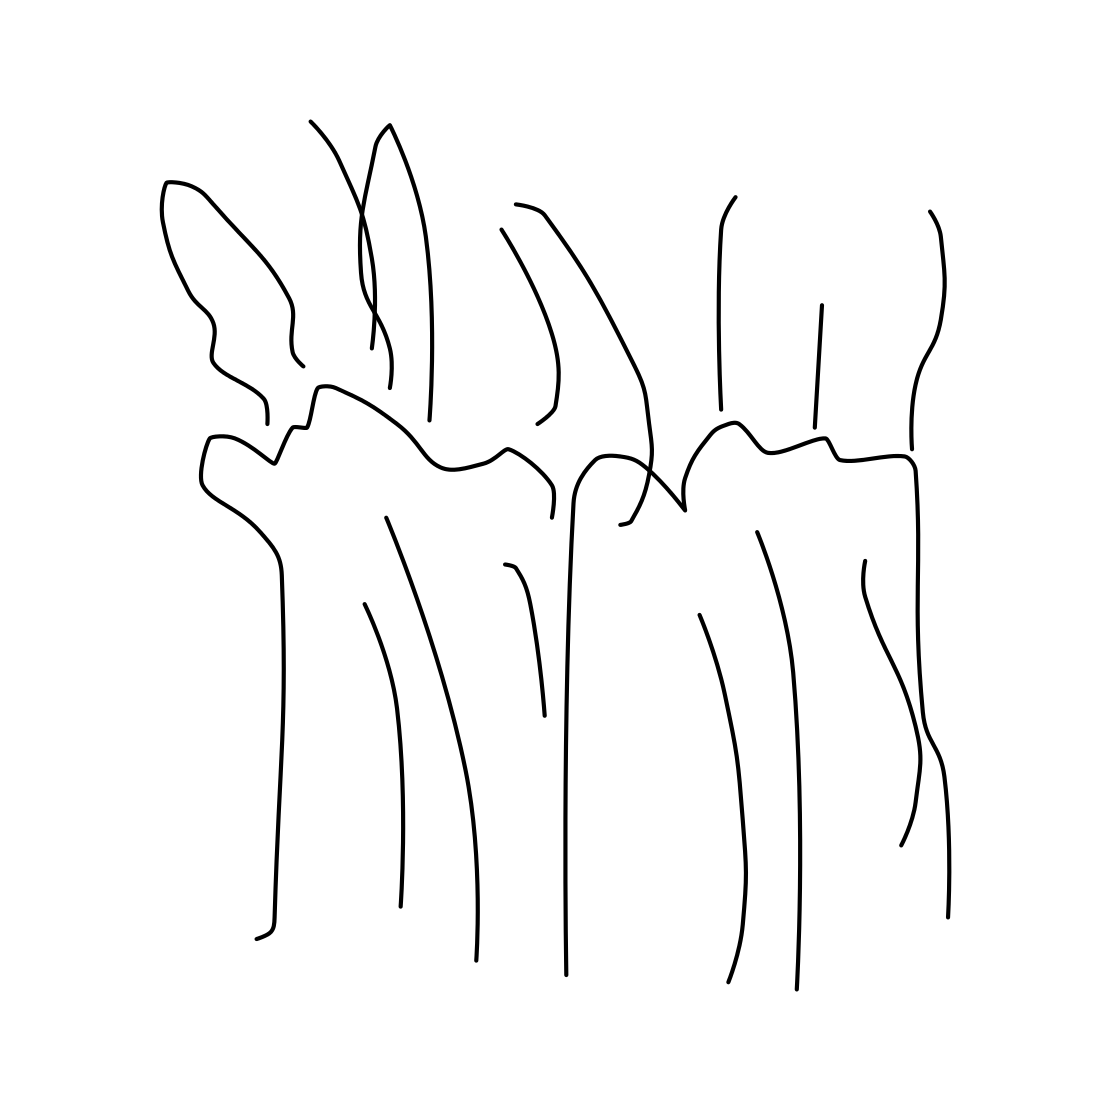In the scene, is an armchair in it? There is no armchair present in the image. The scene only features an abstract line drawing that appears to represent a series of flowing or organic shapes, potentially suggestive of life forms or natural elements. It does not contain any furniture or clear depictions of man-made objects. 